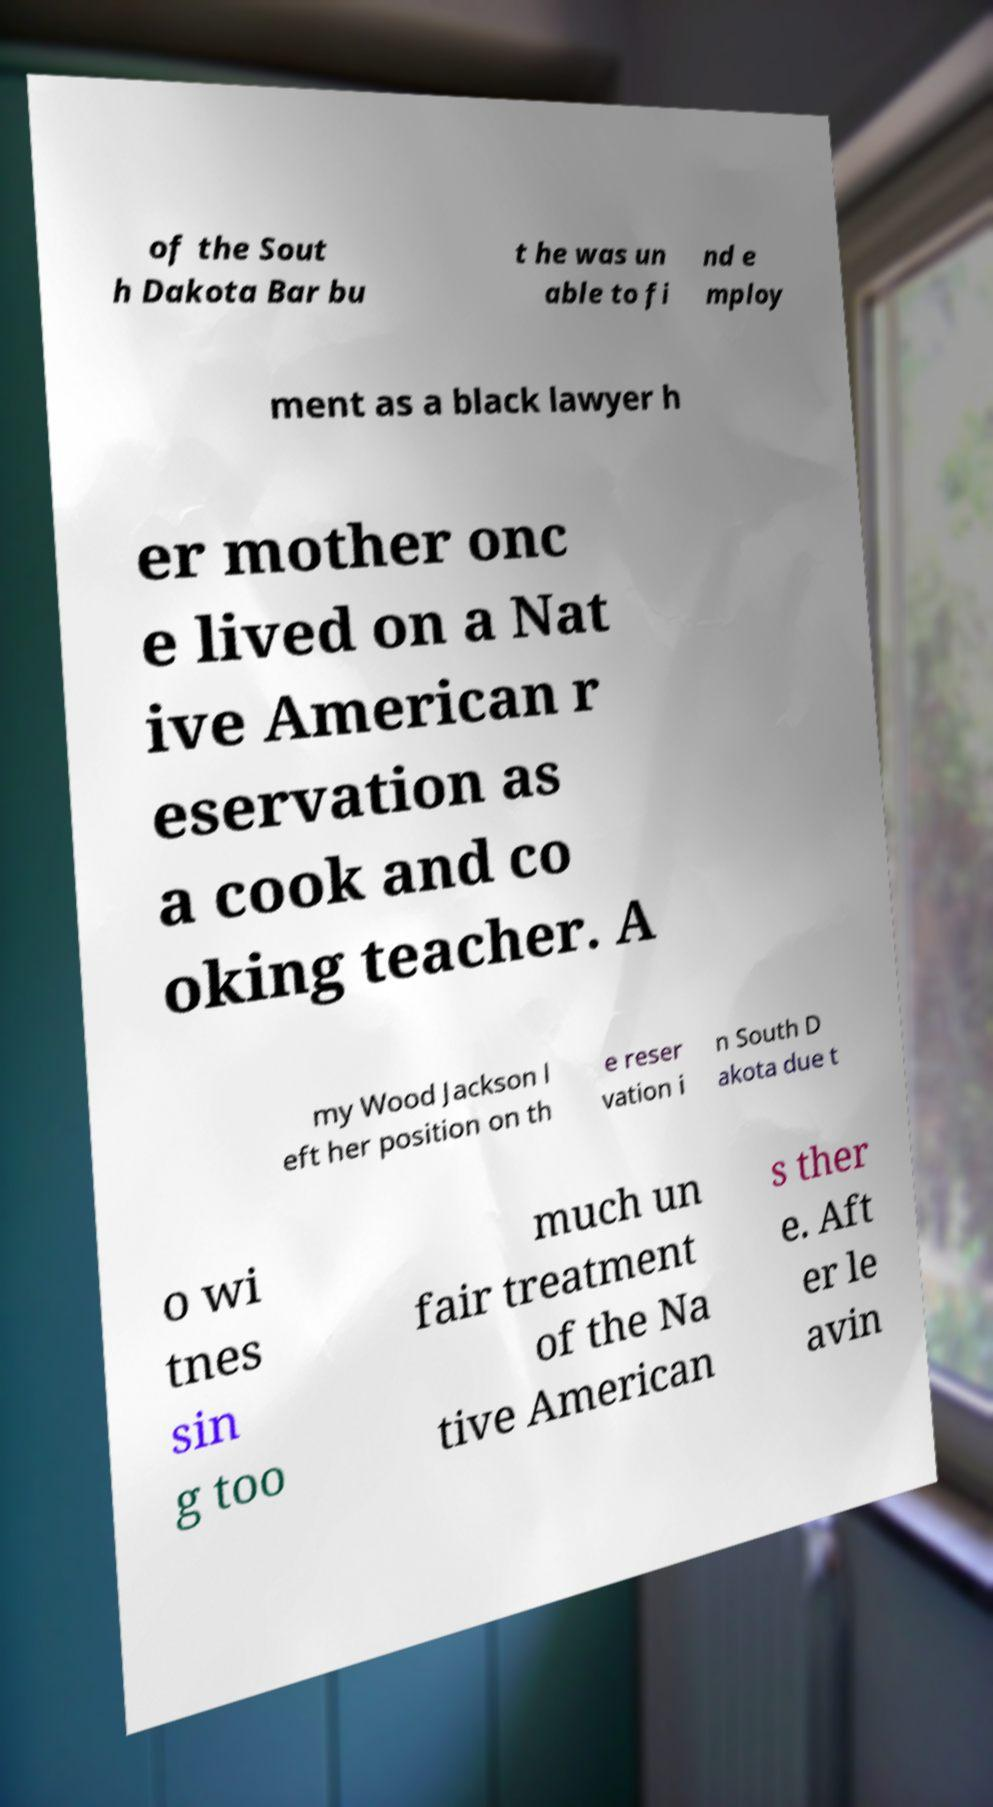For documentation purposes, I need the text within this image transcribed. Could you provide that? of the Sout h Dakota Bar bu t he was un able to fi nd e mploy ment as a black lawyer h er mother onc e lived on a Nat ive American r eservation as a cook and co oking teacher. A my Wood Jackson l eft her position on th e reser vation i n South D akota due t o wi tnes sin g too much un fair treatment of the Na tive American s ther e. Aft er le avin 